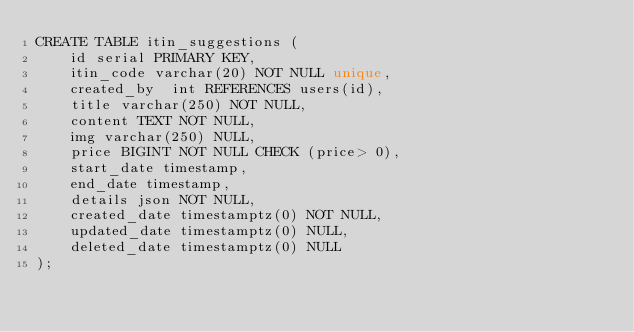<code> <loc_0><loc_0><loc_500><loc_500><_SQL_>CREATE TABLE itin_suggestions (
	id serial PRIMARY KEY,
	itin_code varchar(20) NOT NULL unique,
    created_by  int REFERENCES users(id),
	title varchar(250) NOT NULL,
    content TEXT NOT NULL,
    img varchar(250) NULL,
    price BIGINT NOT NULL CHECK (price> 0),
    start_date timestamp,
    end_date timestamp,
    details json NOT NULL,
    created_date timestamptz(0) NOT NULL,
	updated_date timestamptz(0) NULL,
	deleted_date timestamptz(0) NULL
);</code> 